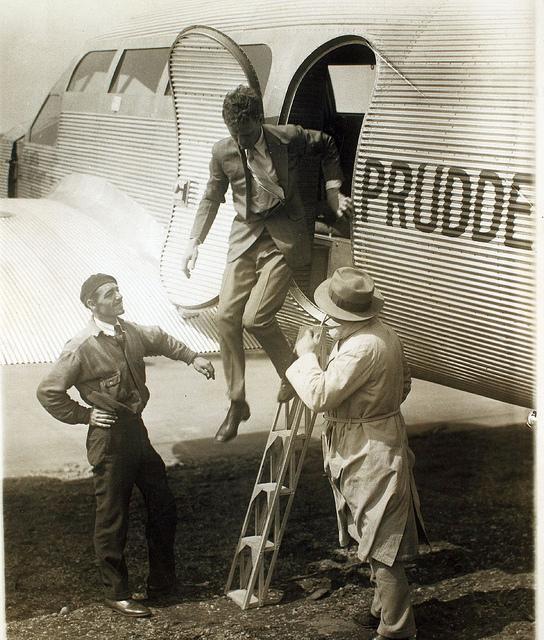How many men are wearing hats?
Give a very brief answer. 1. How many people are visible?
Give a very brief answer. 3. 